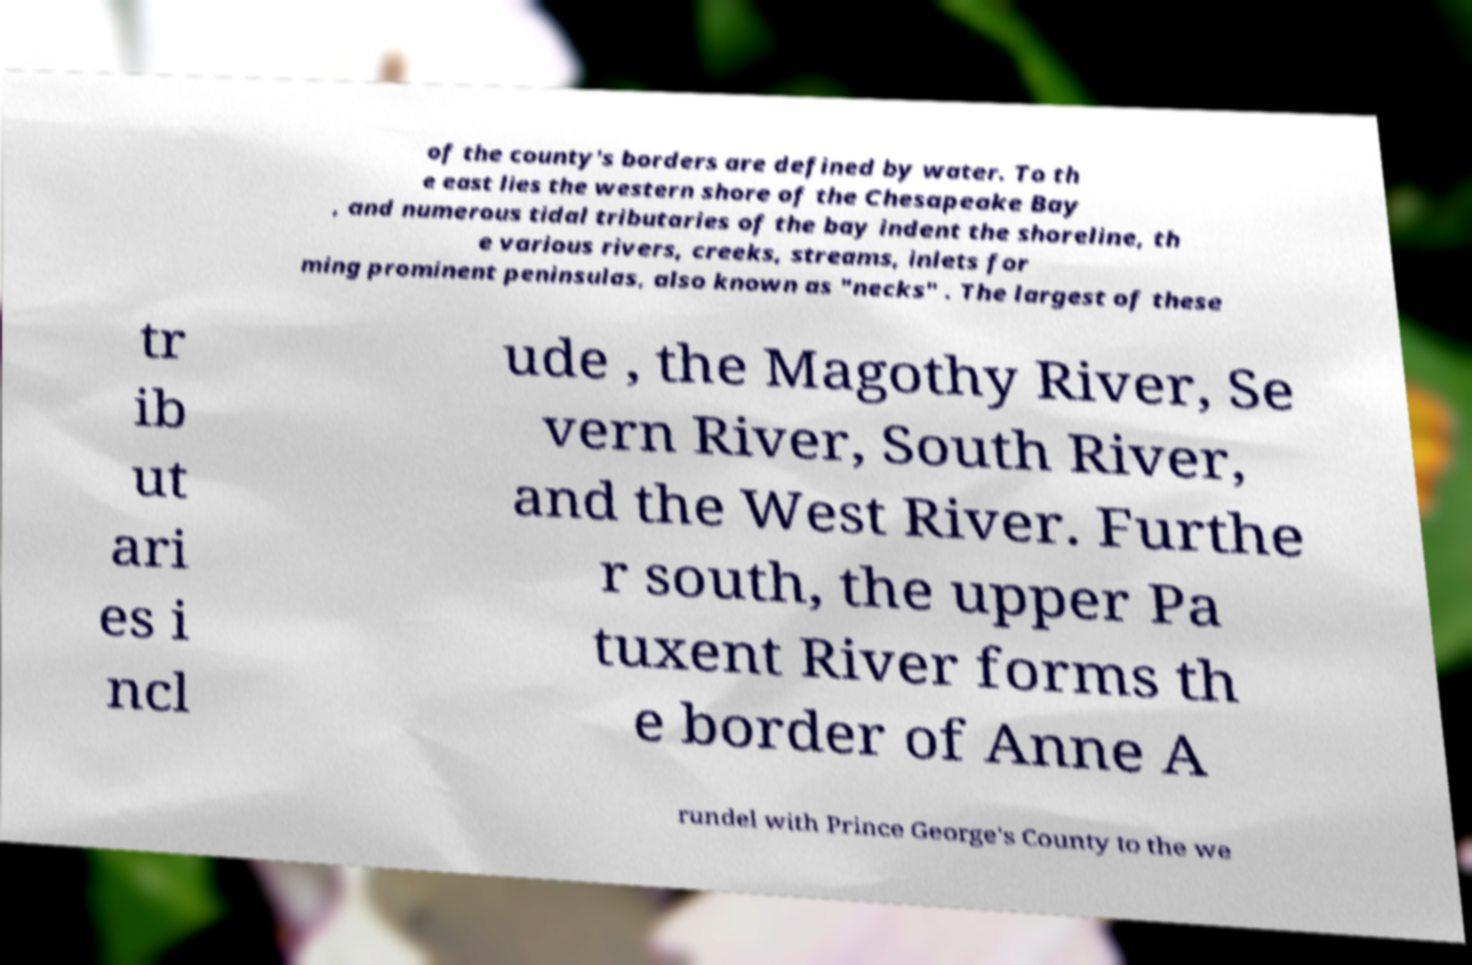For documentation purposes, I need the text within this image transcribed. Could you provide that? of the county's borders are defined by water. To th e east lies the western shore of the Chesapeake Bay , and numerous tidal tributaries of the bay indent the shoreline, th e various rivers, creeks, streams, inlets for ming prominent peninsulas, also known as "necks" . The largest of these tr ib ut ari es i ncl ude , the Magothy River, Se vern River, South River, and the West River. Furthe r south, the upper Pa tuxent River forms th e border of Anne A rundel with Prince George's County to the we 